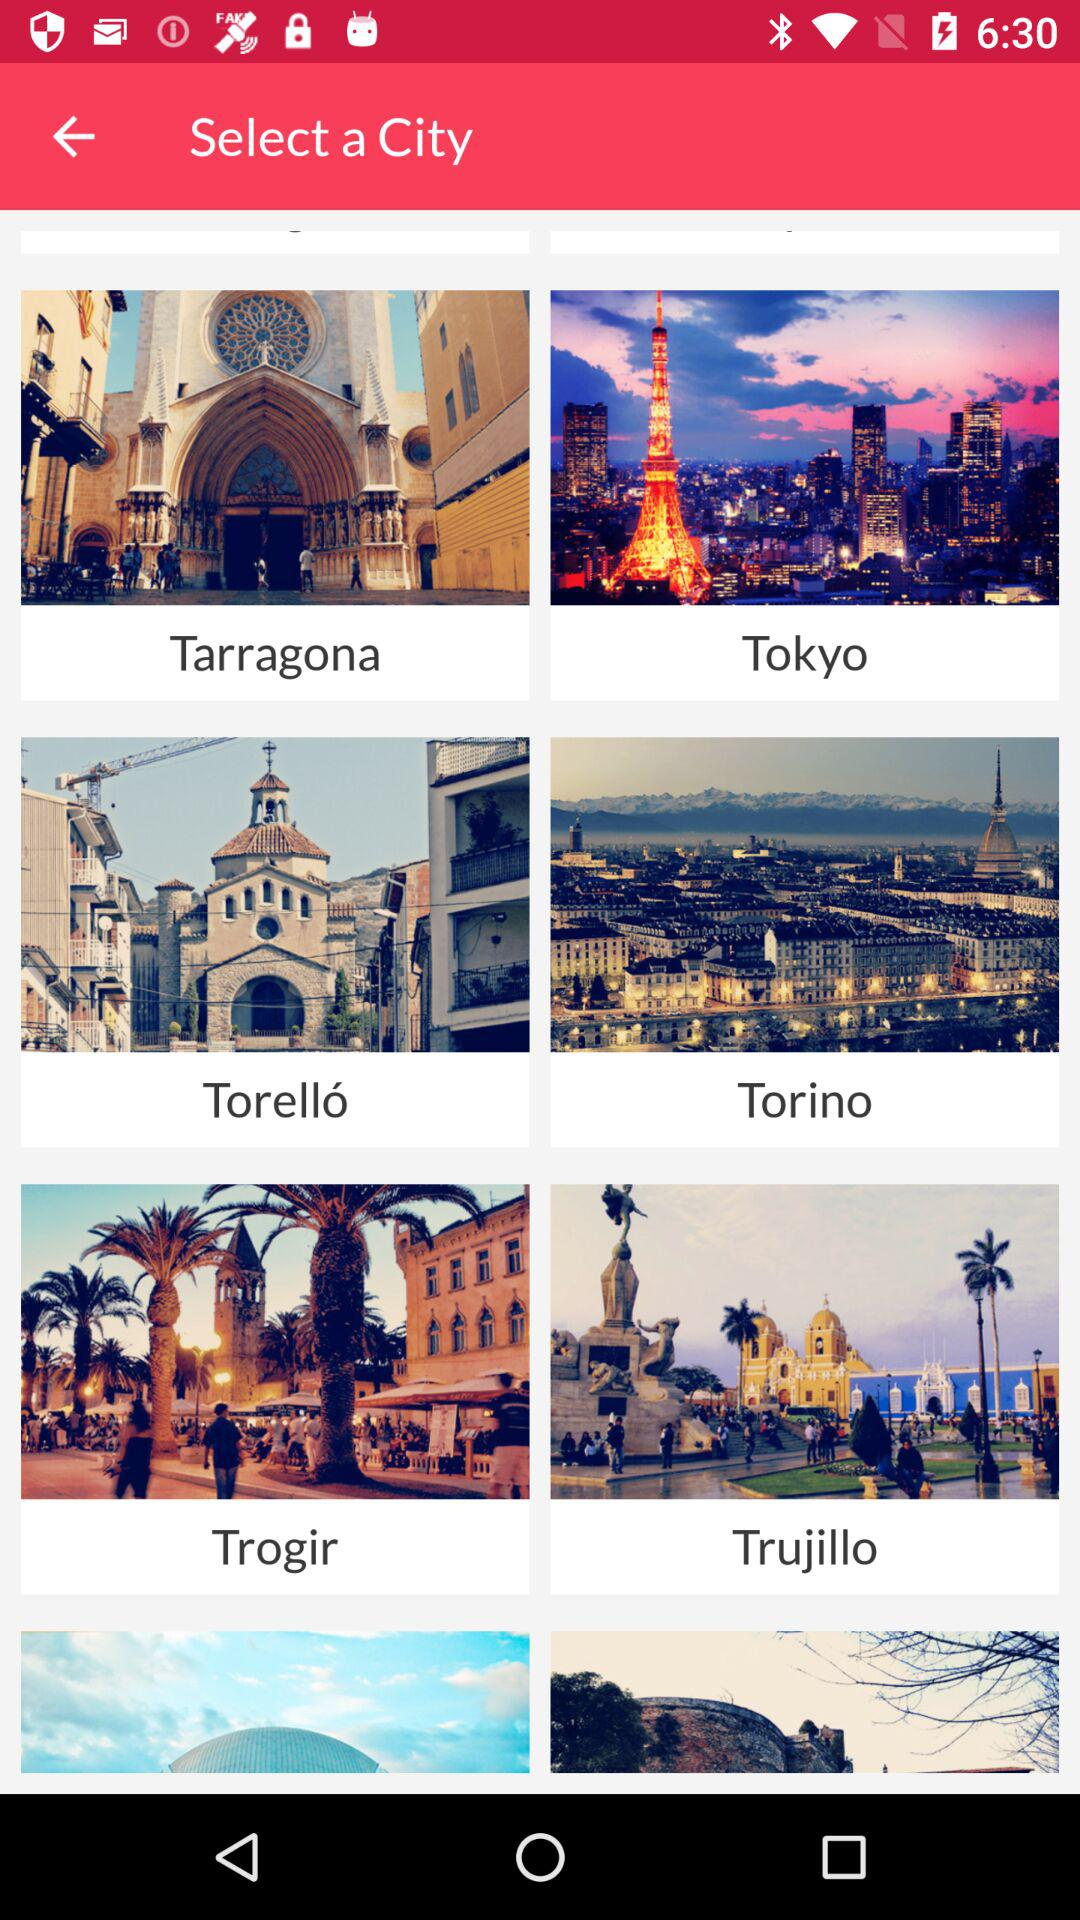What are the different available cities? The different available cities are Tarragona, Tokyo, Torelló, Torino, Trogir and Trujillo. 